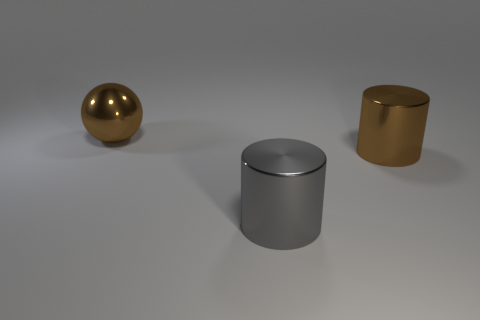Subtract all yellow cylinders. Subtract all green blocks. How many cylinders are left? 2 Add 3 brown metal balls. How many objects exist? 6 Subtract all cylinders. How many objects are left? 1 Subtract all small gray rubber blocks. Subtract all big gray metallic cylinders. How many objects are left? 2 Add 2 brown balls. How many brown balls are left? 3 Add 3 large brown cylinders. How many large brown cylinders exist? 4 Subtract 0 gray blocks. How many objects are left? 3 